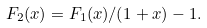<formula> <loc_0><loc_0><loc_500><loc_500>F _ { 2 } ( x ) = F _ { 1 } ( x ) / ( 1 + x ) - 1 .</formula> 